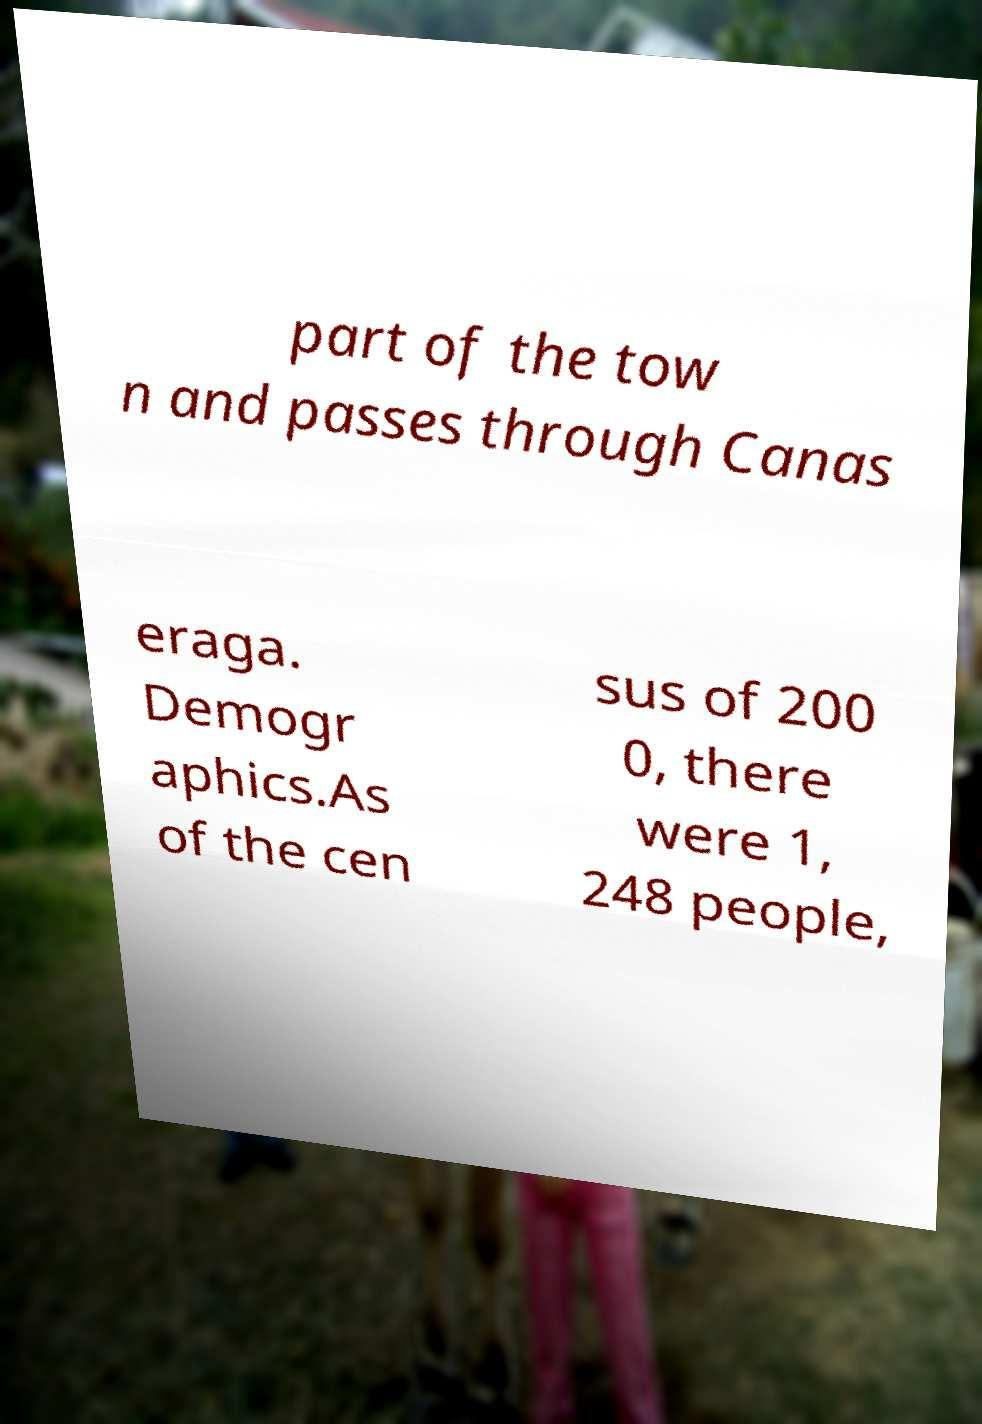Please identify and transcribe the text found in this image. part of the tow n and passes through Canas eraga. Demogr aphics.As of the cen sus of 200 0, there were 1, 248 people, 